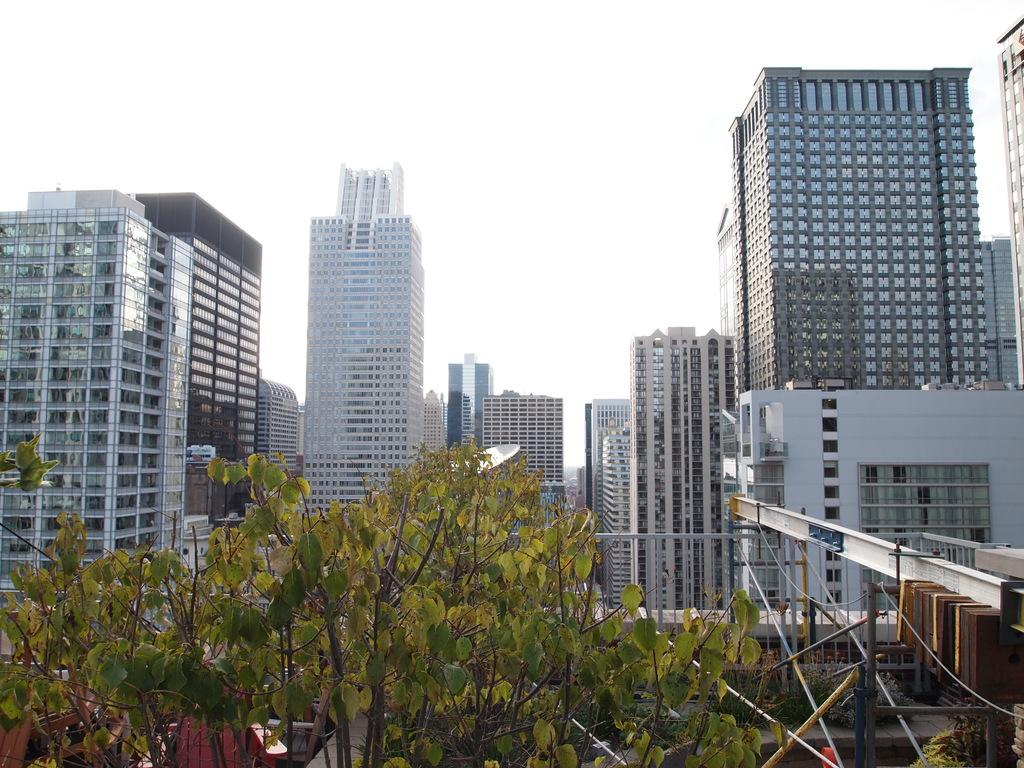What type of natural element can be seen in the image? There is a tree in the image. What can be seen in the background of the image? There is sky and buildings visible in the background of the image. What type of meat is hanging from the tree in the image? There is no meat present in the image; it features a tree and background elements. Can you see a rabbit hiding behind the tree in the image? There is no rabbit present in the image; it only features a tree and background elements. 